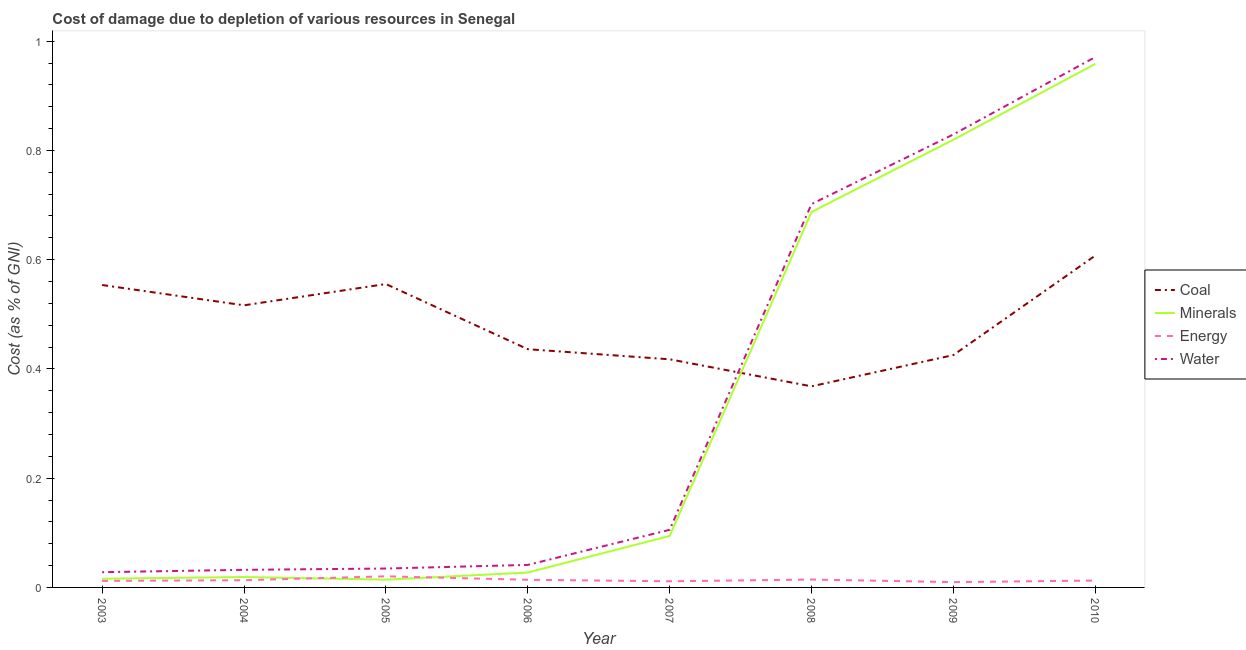How many different coloured lines are there?
Make the answer very short. 4. Does the line corresponding to cost of damage due to depletion of coal intersect with the line corresponding to cost of damage due to depletion of minerals?
Your answer should be compact. Yes. Is the number of lines equal to the number of legend labels?
Your response must be concise. Yes. What is the cost of damage due to depletion of coal in 2010?
Offer a very short reply. 0.61. Across all years, what is the maximum cost of damage due to depletion of water?
Your answer should be very brief. 0.97. Across all years, what is the minimum cost of damage due to depletion of energy?
Offer a terse response. 0.01. In which year was the cost of damage due to depletion of energy maximum?
Offer a terse response. 2005. In which year was the cost of damage due to depletion of energy minimum?
Provide a short and direct response. 2009. What is the total cost of damage due to depletion of minerals in the graph?
Your answer should be compact. 2.64. What is the difference between the cost of damage due to depletion of water in 2003 and that in 2006?
Provide a succinct answer. -0.01. What is the difference between the cost of damage due to depletion of energy in 2006 and the cost of damage due to depletion of coal in 2010?
Your answer should be very brief. -0.59. What is the average cost of damage due to depletion of energy per year?
Ensure brevity in your answer.  0.01. In the year 2009, what is the difference between the cost of damage due to depletion of water and cost of damage due to depletion of coal?
Keep it short and to the point. 0.4. What is the ratio of the cost of damage due to depletion of energy in 2003 to that in 2005?
Your answer should be very brief. 0.59. What is the difference between the highest and the second highest cost of damage due to depletion of coal?
Ensure brevity in your answer.  0.05. What is the difference between the highest and the lowest cost of damage due to depletion of minerals?
Ensure brevity in your answer.  0.94. Is it the case that in every year, the sum of the cost of damage due to depletion of energy and cost of damage due to depletion of minerals is greater than the sum of cost of damage due to depletion of water and cost of damage due to depletion of coal?
Provide a short and direct response. No. Is it the case that in every year, the sum of the cost of damage due to depletion of coal and cost of damage due to depletion of minerals is greater than the cost of damage due to depletion of energy?
Offer a terse response. Yes. Is the cost of damage due to depletion of minerals strictly less than the cost of damage due to depletion of energy over the years?
Make the answer very short. No. How many lines are there?
Your answer should be compact. 4. How many years are there in the graph?
Your answer should be very brief. 8. What is the difference between two consecutive major ticks on the Y-axis?
Offer a very short reply. 0.2. Does the graph contain any zero values?
Offer a very short reply. No. Where does the legend appear in the graph?
Offer a terse response. Center right. How are the legend labels stacked?
Provide a short and direct response. Vertical. What is the title of the graph?
Your response must be concise. Cost of damage due to depletion of various resources in Senegal . Does "Labor Taxes" appear as one of the legend labels in the graph?
Make the answer very short. No. What is the label or title of the Y-axis?
Offer a very short reply. Cost (as % of GNI). What is the Cost (as % of GNI) in Coal in 2003?
Make the answer very short. 0.55. What is the Cost (as % of GNI) of Minerals in 2003?
Ensure brevity in your answer.  0.02. What is the Cost (as % of GNI) in Energy in 2003?
Give a very brief answer. 0.01. What is the Cost (as % of GNI) of Water in 2003?
Make the answer very short. 0.03. What is the Cost (as % of GNI) of Coal in 2004?
Provide a succinct answer. 0.52. What is the Cost (as % of GNI) of Minerals in 2004?
Your answer should be very brief. 0.02. What is the Cost (as % of GNI) of Energy in 2004?
Provide a short and direct response. 0.01. What is the Cost (as % of GNI) of Water in 2004?
Your answer should be very brief. 0.03. What is the Cost (as % of GNI) in Coal in 2005?
Provide a short and direct response. 0.56. What is the Cost (as % of GNI) of Minerals in 2005?
Keep it short and to the point. 0.01. What is the Cost (as % of GNI) of Energy in 2005?
Your answer should be compact. 0.02. What is the Cost (as % of GNI) of Water in 2005?
Your answer should be very brief. 0.03. What is the Cost (as % of GNI) in Coal in 2006?
Make the answer very short. 0.44. What is the Cost (as % of GNI) in Minerals in 2006?
Your response must be concise. 0.03. What is the Cost (as % of GNI) of Energy in 2006?
Provide a succinct answer. 0.01. What is the Cost (as % of GNI) of Water in 2006?
Give a very brief answer. 0.04. What is the Cost (as % of GNI) of Coal in 2007?
Ensure brevity in your answer.  0.42. What is the Cost (as % of GNI) in Minerals in 2007?
Your answer should be compact. 0.09. What is the Cost (as % of GNI) of Energy in 2007?
Offer a terse response. 0.01. What is the Cost (as % of GNI) in Water in 2007?
Keep it short and to the point. 0.11. What is the Cost (as % of GNI) in Coal in 2008?
Your response must be concise. 0.37. What is the Cost (as % of GNI) in Minerals in 2008?
Ensure brevity in your answer.  0.69. What is the Cost (as % of GNI) in Energy in 2008?
Keep it short and to the point. 0.01. What is the Cost (as % of GNI) of Water in 2008?
Make the answer very short. 0.7. What is the Cost (as % of GNI) in Coal in 2009?
Provide a short and direct response. 0.43. What is the Cost (as % of GNI) in Minerals in 2009?
Make the answer very short. 0.82. What is the Cost (as % of GNI) of Energy in 2009?
Ensure brevity in your answer.  0.01. What is the Cost (as % of GNI) of Water in 2009?
Offer a very short reply. 0.83. What is the Cost (as % of GNI) in Coal in 2010?
Provide a short and direct response. 0.61. What is the Cost (as % of GNI) of Minerals in 2010?
Make the answer very short. 0.96. What is the Cost (as % of GNI) in Energy in 2010?
Offer a very short reply. 0.01. What is the Cost (as % of GNI) in Water in 2010?
Offer a terse response. 0.97. Across all years, what is the maximum Cost (as % of GNI) in Coal?
Make the answer very short. 0.61. Across all years, what is the maximum Cost (as % of GNI) of Minerals?
Your response must be concise. 0.96. Across all years, what is the maximum Cost (as % of GNI) of Energy?
Your answer should be very brief. 0.02. Across all years, what is the maximum Cost (as % of GNI) of Water?
Your response must be concise. 0.97. Across all years, what is the minimum Cost (as % of GNI) in Coal?
Provide a short and direct response. 0.37. Across all years, what is the minimum Cost (as % of GNI) of Minerals?
Give a very brief answer. 0.01. Across all years, what is the minimum Cost (as % of GNI) of Energy?
Provide a short and direct response. 0.01. Across all years, what is the minimum Cost (as % of GNI) of Water?
Your response must be concise. 0.03. What is the total Cost (as % of GNI) of Coal in the graph?
Your answer should be compact. 3.88. What is the total Cost (as % of GNI) in Minerals in the graph?
Make the answer very short. 2.64. What is the total Cost (as % of GNI) in Energy in the graph?
Keep it short and to the point. 0.11. What is the total Cost (as % of GNI) in Water in the graph?
Offer a terse response. 2.74. What is the difference between the Cost (as % of GNI) in Coal in 2003 and that in 2004?
Your answer should be compact. 0.04. What is the difference between the Cost (as % of GNI) in Minerals in 2003 and that in 2004?
Keep it short and to the point. -0. What is the difference between the Cost (as % of GNI) in Energy in 2003 and that in 2004?
Offer a very short reply. -0. What is the difference between the Cost (as % of GNI) in Water in 2003 and that in 2004?
Give a very brief answer. -0. What is the difference between the Cost (as % of GNI) in Coal in 2003 and that in 2005?
Your answer should be very brief. -0. What is the difference between the Cost (as % of GNI) in Minerals in 2003 and that in 2005?
Your response must be concise. 0. What is the difference between the Cost (as % of GNI) in Energy in 2003 and that in 2005?
Give a very brief answer. -0.01. What is the difference between the Cost (as % of GNI) in Water in 2003 and that in 2005?
Your answer should be very brief. -0.01. What is the difference between the Cost (as % of GNI) in Coal in 2003 and that in 2006?
Provide a short and direct response. 0.12. What is the difference between the Cost (as % of GNI) in Minerals in 2003 and that in 2006?
Your answer should be compact. -0.01. What is the difference between the Cost (as % of GNI) of Energy in 2003 and that in 2006?
Your answer should be compact. -0. What is the difference between the Cost (as % of GNI) in Water in 2003 and that in 2006?
Your answer should be compact. -0.01. What is the difference between the Cost (as % of GNI) of Coal in 2003 and that in 2007?
Give a very brief answer. 0.14. What is the difference between the Cost (as % of GNI) in Minerals in 2003 and that in 2007?
Your answer should be compact. -0.08. What is the difference between the Cost (as % of GNI) in Energy in 2003 and that in 2007?
Make the answer very short. 0. What is the difference between the Cost (as % of GNI) of Water in 2003 and that in 2007?
Offer a very short reply. -0.08. What is the difference between the Cost (as % of GNI) of Coal in 2003 and that in 2008?
Your response must be concise. 0.19. What is the difference between the Cost (as % of GNI) in Minerals in 2003 and that in 2008?
Your response must be concise. -0.67. What is the difference between the Cost (as % of GNI) in Energy in 2003 and that in 2008?
Ensure brevity in your answer.  -0. What is the difference between the Cost (as % of GNI) in Water in 2003 and that in 2008?
Provide a short and direct response. -0.67. What is the difference between the Cost (as % of GNI) in Coal in 2003 and that in 2009?
Offer a terse response. 0.13. What is the difference between the Cost (as % of GNI) of Minerals in 2003 and that in 2009?
Make the answer very short. -0.8. What is the difference between the Cost (as % of GNI) of Energy in 2003 and that in 2009?
Keep it short and to the point. 0. What is the difference between the Cost (as % of GNI) in Water in 2003 and that in 2009?
Provide a succinct answer. -0.8. What is the difference between the Cost (as % of GNI) of Coal in 2003 and that in 2010?
Give a very brief answer. -0.05. What is the difference between the Cost (as % of GNI) of Minerals in 2003 and that in 2010?
Your answer should be compact. -0.94. What is the difference between the Cost (as % of GNI) of Energy in 2003 and that in 2010?
Make the answer very short. -0. What is the difference between the Cost (as % of GNI) of Water in 2003 and that in 2010?
Your answer should be compact. -0.94. What is the difference between the Cost (as % of GNI) of Coal in 2004 and that in 2005?
Ensure brevity in your answer.  -0.04. What is the difference between the Cost (as % of GNI) of Minerals in 2004 and that in 2005?
Give a very brief answer. 0. What is the difference between the Cost (as % of GNI) in Energy in 2004 and that in 2005?
Your response must be concise. -0.01. What is the difference between the Cost (as % of GNI) of Water in 2004 and that in 2005?
Keep it short and to the point. -0. What is the difference between the Cost (as % of GNI) in Coal in 2004 and that in 2006?
Make the answer very short. 0.08. What is the difference between the Cost (as % of GNI) of Minerals in 2004 and that in 2006?
Your response must be concise. -0.01. What is the difference between the Cost (as % of GNI) of Energy in 2004 and that in 2006?
Your answer should be compact. -0. What is the difference between the Cost (as % of GNI) in Water in 2004 and that in 2006?
Keep it short and to the point. -0.01. What is the difference between the Cost (as % of GNI) of Coal in 2004 and that in 2007?
Offer a terse response. 0.1. What is the difference between the Cost (as % of GNI) in Minerals in 2004 and that in 2007?
Your answer should be compact. -0.08. What is the difference between the Cost (as % of GNI) in Energy in 2004 and that in 2007?
Provide a succinct answer. 0. What is the difference between the Cost (as % of GNI) of Water in 2004 and that in 2007?
Your response must be concise. -0.07. What is the difference between the Cost (as % of GNI) of Coal in 2004 and that in 2008?
Provide a succinct answer. 0.15. What is the difference between the Cost (as % of GNI) of Minerals in 2004 and that in 2008?
Your response must be concise. -0.67. What is the difference between the Cost (as % of GNI) of Energy in 2004 and that in 2008?
Your answer should be compact. -0. What is the difference between the Cost (as % of GNI) in Water in 2004 and that in 2008?
Provide a succinct answer. -0.67. What is the difference between the Cost (as % of GNI) of Coal in 2004 and that in 2009?
Your answer should be compact. 0.09. What is the difference between the Cost (as % of GNI) in Minerals in 2004 and that in 2009?
Offer a terse response. -0.8. What is the difference between the Cost (as % of GNI) in Energy in 2004 and that in 2009?
Your answer should be very brief. 0. What is the difference between the Cost (as % of GNI) of Water in 2004 and that in 2009?
Your response must be concise. -0.8. What is the difference between the Cost (as % of GNI) of Coal in 2004 and that in 2010?
Offer a terse response. -0.09. What is the difference between the Cost (as % of GNI) of Minerals in 2004 and that in 2010?
Provide a short and direct response. -0.94. What is the difference between the Cost (as % of GNI) of Energy in 2004 and that in 2010?
Make the answer very short. 0. What is the difference between the Cost (as % of GNI) of Water in 2004 and that in 2010?
Give a very brief answer. -0.94. What is the difference between the Cost (as % of GNI) of Coal in 2005 and that in 2006?
Ensure brevity in your answer.  0.12. What is the difference between the Cost (as % of GNI) in Minerals in 2005 and that in 2006?
Offer a very short reply. -0.01. What is the difference between the Cost (as % of GNI) of Energy in 2005 and that in 2006?
Offer a terse response. 0.01. What is the difference between the Cost (as % of GNI) in Water in 2005 and that in 2006?
Provide a succinct answer. -0.01. What is the difference between the Cost (as % of GNI) of Coal in 2005 and that in 2007?
Offer a terse response. 0.14. What is the difference between the Cost (as % of GNI) of Minerals in 2005 and that in 2007?
Provide a succinct answer. -0.08. What is the difference between the Cost (as % of GNI) of Energy in 2005 and that in 2007?
Your response must be concise. 0.01. What is the difference between the Cost (as % of GNI) of Water in 2005 and that in 2007?
Your answer should be very brief. -0.07. What is the difference between the Cost (as % of GNI) of Coal in 2005 and that in 2008?
Your answer should be compact. 0.19. What is the difference between the Cost (as % of GNI) in Minerals in 2005 and that in 2008?
Provide a succinct answer. -0.67. What is the difference between the Cost (as % of GNI) of Energy in 2005 and that in 2008?
Your answer should be compact. 0.01. What is the difference between the Cost (as % of GNI) of Water in 2005 and that in 2008?
Your response must be concise. -0.67. What is the difference between the Cost (as % of GNI) of Coal in 2005 and that in 2009?
Keep it short and to the point. 0.13. What is the difference between the Cost (as % of GNI) of Minerals in 2005 and that in 2009?
Make the answer very short. -0.81. What is the difference between the Cost (as % of GNI) of Energy in 2005 and that in 2009?
Keep it short and to the point. 0.01. What is the difference between the Cost (as % of GNI) in Water in 2005 and that in 2009?
Ensure brevity in your answer.  -0.79. What is the difference between the Cost (as % of GNI) of Coal in 2005 and that in 2010?
Your response must be concise. -0.05. What is the difference between the Cost (as % of GNI) in Minerals in 2005 and that in 2010?
Provide a short and direct response. -0.94. What is the difference between the Cost (as % of GNI) of Energy in 2005 and that in 2010?
Keep it short and to the point. 0.01. What is the difference between the Cost (as % of GNI) of Water in 2005 and that in 2010?
Ensure brevity in your answer.  -0.94. What is the difference between the Cost (as % of GNI) in Coal in 2006 and that in 2007?
Ensure brevity in your answer.  0.02. What is the difference between the Cost (as % of GNI) in Minerals in 2006 and that in 2007?
Give a very brief answer. -0.07. What is the difference between the Cost (as % of GNI) in Energy in 2006 and that in 2007?
Give a very brief answer. 0. What is the difference between the Cost (as % of GNI) of Water in 2006 and that in 2007?
Make the answer very short. -0.06. What is the difference between the Cost (as % of GNI) of Coal in 2006 and that in 2008?
Ensure brevity in your answer.  0.07. What is the difference between the Cost (as % of GNI) in Minerals in 2006 and that in 2008?
Offer a very short reply. -0.66. What is the difference between the Cost (as % of GNI) in Energy in 2006 and that in 2008?
Give a very brief answer. -0. What is the difference between the Cost (as % of GNI) in Water in 2006 and that in 2008?
Your answer should be very brief. -0.66. What is the difference between the Cost (as % of GNI) in Coal in 2006 and that in 2009?
Ensure brevity in your answer.  0.01. What is the difference between the Cost (as % of GNI) of Minerals in 2006 and that in 2009?
Offer a terse response. -0.79. What is the difference between the Cost (as % of GNI) of Energy in 2006 and that in 2009?
Give a very brief answer. 0. What is the difference between the Cost (as % of GNI) of Water in 2006 and that in 2009?
Offer a very short reply. -0.79. What is the difference between the Cost (as % of GNI) in Coal in 2006 and that in 2010?
Provide a succinct answer. -0.17. What is the difference between the Cost (as % of GNI) of Minerals in 2006 and that in 2010?
Your answer should be compact. -0.93. What is the difference between the Cost (as % of GNI) in Energy in 2006 and that in 2010?
Provide a succinct answer. 0. What is the difference between the Cost (as % of GNI) in Water in 2006 and that in 2010?
Offer a very short reply. -0.93. What is the difference between the Cost (as % of GNI) of Coal in 2007 and that in 2008?
Give a very brief answer. 0.05. What is the difference between the Cost (as % of GNI) in Minerals in 2007 and that in 2008?
Your answer should be very brief. -0.59. What is the difference between the Cost (as % of GNI) of Energy in 2007 and that in 2008?
Offer a very short reply. -0. What is the difference between the Cost (as % of GNI) of Water in 2007 and that in 2008?
Your response must be concise. -0.6. What is the difference between the Cost (as % of GNI) in Coal in 2007 and that in 2009?
Make the answer very short. -0.01. What is the difference between the Cost (as % of GNI) of Minerals in 2007 and that in 2009?
Keep it short and to the point. -0.73. What is the difference between the Cost (as % of GNI) of Energy in 2007 and that in 2009?
Offer a terse response. 0. What is the difference between the Cost (as % of GNI) in Water in 2007 and that in 2009?
Ensure brevity in your answer.  -0.72. What is the difference between the Cost (as % of GNI) of Coal in 2007 and that in 2010?
Keep it short and to the point. -0.19. What is the difference between the Cost (as % of GNI) of Minerals in 2007 and that in 2010?
Give a very brief answer. -0.86. What is the difference between the Cost (as % of GNI) of Energy in 2007 and that in 2010?
Make the answer very short. -0. What is the difference between the Cost (as % of GNI) in Water in 2007 and that in 2010?
Provide a succinct answer. -0.87. What is the difference between the Cost (as % of GNI) of Coal in 2008 and that in 2009?
Your answer should be compact. -0.06. What is the difference between the Cost (as % of GNI) of Minerals in 2008 and that in 2009?
Keep it short and to the point. -0.13. What is the difference between the Cost (as % of GNI) in Energy in 2008 and that in 2009?
Give a very brief answer. 0. What is the difference between the Cost (as % of GNI) in Water in 2008 and that in 2009?
Offer a terse response. -0.13. What is the difference between the Cost (as % of GNI) of Coal in 2008 and that in 2010?
Provide a succinct answer. -0.24. What is the difference between the Cost (as % of GNI) in Minerals in 2008 and that in 2010?
Your response must be concise. -0.27. What is the difference between the Cost (as % of GNI) in Energy in 2008 and that in 2010?
Offer a very short reply. 0. What is the difference between the Cost (as % of GNI) in Water in 2008 and that in 2010?
Provide a succinct answer. -0.27. What is the difference between the Cost (as % of GNI) in Coal in 2009 and that in 2010?
Provide a short and direct response. -0.18. What is the difference between the Cost (as % of GNI) in Minerals in 2009 and that in 2010?
Make the answer very short. -0.14. What is the difference between the Cost (as % of GNI) of Energy in 2009 and that in 2010?
Your answer should be compact. -0. What is the difference between the Cost (as % of GNI) in Water in 2009 and that in 2010?
Provide a succinct answer. -0.14. What is the difference between the Cost (as % of GNI) in Coal in 2003 and the Cost (as % of GNI) in Minerals in 2004?
Your response must be concise. 0.53. What is the difference between the Cost (as % of GNI) of Coal in 2003 and the Cost (as % of GNI) of Energy in 2004?
Provide a short and direct response. 0.54. What is the difference between the Cost (as % of GNI) of Coal in 2003 and the Cost (as % of GNI) of Water in 2004?
Provide a succinct answer. 0.52. What is the difference between the Cost (as % of GNI) in Minerals in 2003 and the Cost (as % of GNI) in Energy in 2004?
Provide a short and direct response. 0. What is the difference between the Cost (as % of GNI) in Minerals in 2003 and the Cost (as % of GNI) in Water in 2004?
Offer a terse response. -0.02. What is the difference between the Cost (as % of GNI) in Energy in 2003 and the Cost (as % of GNI) in Water in 2004?
Your response must be concise. -0.02. What is the difference between the Cost (as % of GNI) of Coal in 2003 and the Cost (as % of GNI) of Minerals in 2005?
Offer a very short reply. 0.54. What is the difference between the Cost (as % of GNI) in Coal in 2003 and the Cost (as % of GNI) in Energy in 2005?
Offer a terse response. 0.53. What is the difference between the Cost (as % of GNI) in Coal in 2003 and the Cost (as % of GNI) in Water in 2005?
Offer a terse response. 0.52. What is the difference between the Cost (as % of GNI) of Minerals in 2003 and the Cost (as % of GNI) of Energy in 2005?
Your answer should be compact. -0. What is the difference between the Cost (as % of GNI) in Minerals in 2003 and the Cost (as % of GNI) in Water in 2005?
Your answer should be compact. -0.02. What is the difference between the Cost (as % of GNI) of Energy in 2003 and the Cost (as % of GNI) of Water in 2005?
Offer a very short reply. -0.02. What is the difference between the Cost (as % of GNI) of Coal in 2003 and the Cost (as % of GNI) of Minerals in 2006?
Keep it short and to the point. 0.53. What is the difference between the Cost (as % of GNI) of Coal in 2003 and the Cost (as % of GNI) of Energy in 2006?
Keep it short and to the point. 0.54. What is the difference between the Cost (as % of GNI) of Coal in 2003 and the Cost (as % of GNI) of Water in 2006?
Ensure brevity in your answer.  0.51. What is the difference between the Cost (as % of GNI) of Minerals in 2003 and the Cost (as % of GNI) of Energy in 2006?
Ensure brevity in your answer.  0. What is the difference between the Cost (as % of GNI) in Minerals in 2003 and the Cost (as % of GNI) in Water in 2006?
Your response must be concise. -0.03. What is the difference between the Cost (as % of GNI) in Energy in 2003 and the Cost (as % of GNI) in Water in 2006?
Ensure brevity in your answer.  -0.03. What is the difference between the Cost (as % of GNI) of Coal in 2003 and the Cost (as % of GNI) of Minerals in 2007?
Provide a succinct answer. 0.46. What is the difference between the Cost (as % of GNI) of Coal in 2003 and the Cost (as % of GNI) of Energy in 2007?
Give a very brief answer. 0.54. What is the difference between the Cost (as % of GNI) of Coal in 2003 and the Cost (as % of GNI) of Water in 2007?
Provide a short and direct response. 0.45. What is the difference between the Cost (as % of GNI) of Minerals in 2003 and the Cost (as % of GNI) of Energy in 2007?
Offer a terse response. 0. What is the difference between the Cost (as % of GNI) of Minerals in 2003 and the Cost (as % of GNI) of Water in 2007?
Give a very brief answer. -0.09. What is the difference between the Cost (as % of GNI) in Energy in 2003 and the Cost (as % of GNI) in Water in 2007?
Provide a succinct answer. -0.09. What is the difference between the Cost (as % of GNI) of Coal in 2003 and the Cost (as % of GNI) of Minerals in 2008?
Ensure brevity in your answer.  -0.13. What is the difference between the Cost (as % of GNI) of Coal in 2003 and the Cost (as % of GNI) of Energy in 2008?
Your answer should be very brief. 0.54. What is the difference between the Cost (as % of GNI) in Coal in 2003 and the Cost (as % of GNI) in Water in 2008?
Provide a succinct answer. -0.15. What is the difference between the Cost (as % of GNI) in Minerals in 2003 and the Cost (as % of GNI) in Energy in 2008?
Offer a very short reply. 0. What is the difference between the Cost (as % of GNI) of Minerals in 2003 and the Cost (as % of GNI) of Water in 2008?
Your answer should be compact. -0.69. What is the difference between the Cost (as % of GNI) of Energy in 2003 and the Cost (as % of GNI) of Water in 2008?
Ensure brevity in your answer.  -0.69. What is the difference between the Cost (as % of GNI) in Coal in 2003 and the Cost (as % of GNI) in Minerals in 2009?
Your answer should be compact. -0.27. What is the difference between the Cost (as % of GNI) in Coal in 2003 and the Cost (as % of GNI) in Energy in 2009?
Offer a very short reply. 0.54. What is the difference between the Cost (as % of GNI) of Coal in 2003 and the Cost (as % of GNI) of Water in 2009?
Your response must be concise. -0.28. What is the difference between the Cost (as % of GNI) of Minerals in 2003 and the Cost (as % of GNI) of Energy in 2009?
Your answer should be compact. 0.01. What is the difference between the Cost (as % of GNI) of Minerals in 2003 and the Cost (as % of GNI) of Water in 2009?
Provide a short and direct response. -0.81. What is the difference between the Cost (as % of GNI) in Energy in 2003 and the Cost (as % of GNI) in Water in 2009?
Offer a very short reply. -0.82. What is the difference between the Cost (as % of GNI) of Coal in 2003 and the Cost (as % of GNI) of Minerals in 2010?
Keep it short and to the point. -0.4. What is the difference between the Cost (as % of GNI) of Coal in 2003 and the Cost (as % of GNI) of Energy in 2010?
Your answer should be very brief. 0.54. What is the difference between the Cost (as % of GNI) in Coal in 2003 and the Cost (as % of GNI) in Water in 2010?
Keep it short and to the point. -0.42. What is the difference between the Cost (as % of GNI) of Minerals in 2003 and the Cost (as % of GNI) of Energy in 2010?
Keep it short and to the point. 0. What is the difference between the Cost (as % of GNI) of Minerals in 2003 and the Cost (as % of GNI) of Water in 2010?
Ensure brevity in your answer.  -0.95. What is the difference between the Cost (as % of GNI) in Energy in 2003 and the Cost (as % of GNI) in Water in 2010?
Offer a very short reply. -0.96. What is the difference between the Cost (as % of GNI) in Coal in 2004 and the Cost (as % of GNI) in Minerals in 2005?
Your answer should be compact. 0.5. What is the difference between the Cost (as % of GNI) in Coal in 2004 and the Cost (as % of GNI) in Energy in 2005?
Your response must be concise. 0.5. What is the difference between the Cost (as % of GNI) in Coal in 2004 and the Cost (as % of GNI) in Water in 2005?
Offer a terse response. 0.48. What is the difference between the Cost (as % of GNI) of Minerals in 2004 and the Cost (as % of GNI) of Energy in 2005?
Make the answer very short. -0. What is the difference between the Cost (as % of GNI) of Minerals in 2004 and the Cost (as % of GNI) of Water in 2005?
Your response must be concise. -0.02. What is the difference between the Cost (as % of GNI) of Energy in 2004 and the Cost (as % of GNI) of Water in 2005?
Provide a succinct answer. -0.02. What is the difference between the Cost (as % of GNI) in Coal in 2004 and the Cost (as % of GNI) in Minerals in 2006?
Your response must be concise. 0.49. What is the difference between the Cost (as % of GNI) of Coal in 2004 and the Cost (as % of GNI) of Energy in 2006?
Offer a terse response. 0.5. What is the difference between the Cost (as % of GNI) in Coal in 2004 and the Cost (as % of GNI) in Water in 2006?
Offer a very short reply. 0.48. What is the difference between the Cost (as % of GNI) of Minerals in 2004 and the Cost (as % of GNI) of Energy in 2006?
Ensure brevity in your answer.  0.01. What is the difference between the Cost (as % of GNI) in Minerals in 2004 and the Cost (as % of GNI) in Water in 2006?
Ensure brevity in your answer.  -0.02. What is the difference between the Cost (as % of GNI) in Energy in 2004 and the Cost (as % of GNI) in Water in 2006?
Provide a short and direct response. -0.03. What is the difference between the Cost (as % of GNI) in Coal in 2004 and the Cost (as % of GNI) in Minerals in 2007?
Make the answer very short. 0.42. What is the difference between the Cost (as % of GNI) of Coal in 2004 and the Cost (as % of GNI) of Energy in 2007?
Your answer should be very brief. 0.51. What is the difference between the Cost (as % of GNI) of Coal in 2004 and the Cost (as % of GNI) of Water in 2007?
Keep it short and to the point. 0.41. What is the difference between the Cost (as % of GNI) in Minerals in 2004 and the Cost (as % of GNI) in Energy in 2007?
Provide a short and direct response. 0.01. What is the difference between the Cost (as % of GNI) of Minerals in 2004 and the Cost (as % of GNI) of Water in 2007?
Your answer should be compact. -0.09. What is the difference between the Cost (as % of GNI) of Energy in 2004 and the Cost (as % of GNI) of Water in 2007?
Provide a succinct answer. -0.09. What is the difference between the Cost (as % of GNI) of Coal in 2004 and the Cost (as % of GNI) of Minerals in 2008?
Your answer should be very brief. -0.17. What is the difference between the Cost (as % of GNI) in Coal in 2004 and the Cost (as % of GNI) in Energy in 2008?
Your answer should be compact. 0.5. What is the difference between the Cost (as % of GNI) of Coal in 2004 and the Cost (as % of GNI) of Water in 2008?
Ensure brevity in your answer.  -0.19. What is the difference between the Cost (as % of GNI) in Minerals in 2004 and the Cost (as % of GNI) in Energy in 2008?
Your answer should be compact. 0. What is the difference between the Cost (as % of GNI) of Minerals in 2004 and the Cost (as % of GNI) of Water in 2008?
Your answer should be compact. -0.68. What is the difference between the Cost (as % of GNI) of Energy in 2004 and the Cost (as % of GNI) of Water in 2008?
Your response must be concise. -0.69. What is the difference between the Cost (as % of GNI) of Coal in 2004 and the Cost (as % of GNI) of Minerals in 2009?
Provide a succinct answer. -0.3. What is the difference between the Cost (as % of GNI) in Coal in 2004 and the Cost (as % of GNI) in Energy in 2009?
Offer a terse response. 0.51. What is the difference between the Cost (as % of GNI) in Coal in 2004 and the Cost (as % of GNI) in Water in 2009?
Your response must be concise. -0.31. What is the difference between the Cost (as % of GNI) in Minerals in 2004 and the Cost (as % of GNI) in Energy in 2009?
Provide a succinct answer. 0.01. What is the difference between the Cost (as % of GNI) in Minerals in 2004 and the Cost (as % of GNI) in Water in 2009?
Provide a succinct answer. -0.81. What is the difference between the Cost (as % of GNI) of Energy in 2004 and the Cost (as % of GNI) of Water in 2009?
Provide a succinct answer. -0.82. What is the difference between the Cost (as % of GNI) in Coal in 2004 and the Cost (as % of GNI) in Minerals in 2010?
Keep it short and to the point. -0.44. What is the difference between the Cost (as % of GNI) of Coal in 2004 and the Cost (as % of GNI) of Energy in 2010?
Provide a short and direct response. 0.5. What is the difference between the Cost (as % of GNI) in Coal in 2004 and the Cost (as % of GNI) in Water in 2010?
Provide a short and direct response. -0.45. What is the difference between the Cost (as % of GNI) of Minerals in 2004 and the Cost (as % of GNI) of Energy in 2010?
Your answer should be very brief. 0.01. What is the difference between the Cost (as % of GNI) in Minerals in 2004 and the Cost (as % of GNI) in Water in 2010?
Provide a succinct answer. -0.95. What is the difference between the Cost (as % of GNI) of Energy in 2004 and the Cost (as % of GNI) of Water in 2010?
Give a very brief answer. -0.96. What is the difference between the Cost (as % of GNI) of Coal in 2005 and the Cost (as % of GNI) of Minerals in 2006?
Make the answer very short. 0.53. What is the difference between the Cost (as % of GNI) in Coal in 2005 and the Cost (as % of GNI) in Energy in 2006?
Give a very brief answer. 0.54. What is the difference between the Cost (as % of GNI) of Coal in 2005 and the Cost (as % of GNI) of Water in 2006?
Your response must be concise. 0.51. What is the difference between the Cost (as % of GNI) of Minerals in 2005 and the Cost (as % of GNI) of Water in 2006?
Give a very brief answer. -0.03. What is the difference between the Cost (as % of GNI) in Energy in 2005 and the Cost (as % of GNI) in Water in 2006?
Your answer should be very brief. -0.02. What is the difference between the Cost (as % of GNI) of Coal in 2005 and the Cost (as % of GNI) of Minerals in 2007?
Your answer should be very brief. 0.46. What is the difference between the Cost (as % of GNI) in Coal in 2005 and the Cost (as % of GNI) in Energy in 2007?
Provide a short and direct response. 0.54. What is the difference between the Cost (as % of GNI) of Coal in 2005 and the Cost (as % of GNI) of Water in 2007?
Provide a succinct answer. 0.45. What is the difference between the Cost (as % of GNI) of Minerals in 2005 and the Cost (as % of GNI) of Energy in 2007?
Keep it short and to the point. 0. What is the difference between the Cost (as % of GNI) in Minerals in 2005 and the Cost (as % of GNI) in Water in 2007?
Your answer should be compact. -0.09. What is the difference between the Cost (as % of GNI) of Energy in 2005 and the Cost (as % of GNI) of Water in 2007?
Your answer should be compact. -0.09. What is the difference between the Cost (as % of GNI) in Coal in 2005 and the Cost (as % of GNI) in Minerals in 2008?
Provide a short and direct response. -0.13. What is the difference between the Cost (as % of GNI) in Coal in 2005 and the Cost (as % of GNI) in Energy in 2008?
Your response must be concise. 0.54. What is the difference between the Cost (as % of GNI) in Coal in 2005 and the Cost (as % of GNI) in Water in 2008?
Make the answer very short. -0.15. What is the difference between the Cost (as % of GNI) of Minerals in 2005 and the Cost (as % of GNI) of Energy in 2008?
Offer a terse response. -0. What is the difference between the Cost (as % of GNI) in Minerals in 2005 and the Cost (as % of GNI) in Water in 2008?
Your response must be concise. -0.69. What is the difference between the Cost (as % of GNI) in Energy in 2005 and the Cost (as % of GNI) in Water in 2008?
Provide a short and direct response. -0.68. What is the difference between the Cost (as % of GNI) in Coal in 2005 and the Cost (as % of GNI) in Minerals in 2009?
Provide a short and direct response. -0.26. What is the difference between the Cost (as % of GNI) of Coal in 2005 and the Cost (as % of GNI) of Energy in 2009?
Ensure brevity in your answer.  0.55. What is the difference between the Cost (as % of GNI) of Coal in 2005 and the Cost (as % of GNI) of Water in 2009?
Give a very brief answer. -0.27. What is the difference between the Cost (as % of GNI) in Minerals in 2005 and the Cost (as % of GNI) in Energy in 2009?
Make the answer very short. 0. What is the difference between the Cost (as % of GNI) of Minerals in 2005 and the Cost (as % of GNI) of Water in 2009?
Offer a very short reply. -0.82. What is the difference between the Cost (as % of GNI) in Energy in 2005 and the Cost (as % of GNI) in Water in 2009?
Provide a short and direct response. -0.81. What is the difference between the Cost (as % of GNI) in Coal in 2005 and the Cost (as % of GNI) in Minerals in 2010?
Offer a very short reply. -0.4. What is the difference between the Cost (as % of GNI) in Coal in 2005 and the Cost (as % of GNI) in Energy in 2010?
Ensure brevity in your answer.  0.54. What is the difference between the Cost (as % of GNI) of Coal in 2005 and the Cost (as % of GNI) of Water in 2010?
Keep it short and to the point. -0.42. What is the difference between the Cost (as % of GNI) in Minerals in 2005 and the Cost (as % of GNI) in Energy in 2010?
Make the answer very short. 0. What is the difference between the Cost (as % of GNI) of Minerals in 2005 and the Cost (as % of GNI) of Water in 2010?
Give a very brief answer. -0.96. What is the difference between the Cost (as % of GNI) of Energy in 2005 and the Cost (as % of GNI) of Water in 2010?
Keep it short and to the point. -0.95. What is the difference between the Cost (as % of GNI) in Coal in 2006 and the Cost (as % of GNI) in Minerals in 2007?
Your response must be concise. 0.34. What is the difference between the Cost (as % of GNI) of Coal in 2006 and the Cost (as % of GNI) of Energy in 2007?
Offer a very short reply. 0.42. What is the difference between the Cost (as % of GNI) in Coal in 2006 and the Cost (as % of GNI) in Water in 2007?
Offer a very short reply. 0.33. What is the difference between the Cost (as % of GNI) in Minerals in 2006 and the Cost (as % of GNI) in Energy in 2007?
Offer a terse response. 0.02. What is the difference between the Cost (as % of GNI) of Minerals in 2006 and the Cost (as % of GNI) of Water in 2007?
Provide a succinct answer. -0.08. What is the difference between the Cost (as % of GNI) of Energy in 2006 and the Cost (as % of GNI) of Water in 2007?
Your response must be concise. -0.09. What is the difference between the Cost (as % of GNI) in Coal in 2006 and the Cost (as % of GNI) in Minerals in 2008?
Ensure brevity in your answer.  -0.25. What is the difference between the Cost (as % of GNI) in Coal in 2006 and the Cost (as % of GNI) in Energy in 2008?
Your response must be concise. 0.42. What is the difference between the Cost (as % of GNI) in Coal in 2006 and the Cost (as % of GNI) in Water in 2008?
Your response must be concise. -0.27. What is the difference between the Cost (as % of GNI) in Minerals in 2006 and the Cost (as % of GNI) in Energy in 2008?
Offer a very short reply. 0.01. What is the difference between the Cost (as % of GNI) in Minerals in 2006 and the Cost (as % of GNI) in Water in 2008?
Provide a short and direct response. -0.67. What is the difference between the Cost (as % of GNI) of Energy in 2006 and the Cost (as % of GNI) of Water in 2008?
Make the answer very short. -0.69. What is the difference between the Cost (as % of GNI) of Coal in 2006 and the Cost (as % of GNI) of Minerals in 2009?
Ensure brevity in your answer.  -0.38. What is the difference between the Cost (as % of GNI) in Coal in 2006 and the Cost (as % of GNI) in Energy in 2009?
Your response must be concise. 0.43. What is the difference between the Cost (as % of GNI) of Coal in 2006 and the Cost (as % of GNI) of Water in 2009?
Provide a succinct answer. -0.39. What is the difference between the Cost (as % of GNI) in Minerals in 2006 and the Cost (as % of GNI) in Energy in 2009?
Offer a terse response. 0.02. What is the difference between the Cost (as % of GNI) of Minerals in 2006 and the Cost (as % of GNI) of Water in 2009?
Your response must be concise. -0.8. What is the difference between the Cost (as % of GNI) of Energy in 2006 and the Cost (as % of GNI) of Water in 2009?
Offer a very short reply. -0.82. What is the difference between the Cost (as % of GNI) of Coal in 2006 and the Cost (as % of GNI) of Minerals in 2010?
Provide a succinct answer. -0.52. What is the difference between the Cost (as % of GNI) in Coal in 2006 and the Cost (as % of GNI) in Energy in 2010?
Offer a terse response. 0.42. What is the difference between the Cost (as % of GNI) of Coal in 2006 and the Cost (as % of GNI) of Water in 2010?
Your answer should be compact. -0.53. What is the difference between the Cost (as % of GNI) in Minerals in 2006 and the Cost (as % of GNI) in Energy in 2010?
Your response must be concise. 0.01. What is the difference between the Cost (as % of GNI) of Minerals in 2006 and the Cost (as % of GNI) of Water in 2010?
Your answer should be very brief. -0.94. What is the difference between the Cost (as % of GNI) of Energy in 2006 and the Cost (as % of GNI) of Water in 2010?
Make the answer very short. -0.96. What is the difference between the Cost (as % of GNI) of Coal in 2007 and the Cost (as % of GNI) of Minerals in 2008?
Make the answer very short. -0.27. What is the difference between the Cost (as % of GNI) of Coal in 2007 and the Cost (as % of GNI) of Energy in 2008?
Provide a short and direct response. 0.4. What is the difference between the Cost (as % of GNI) of Coal in 2007 and the Cost (as % of GNI) of Water in 2008?
Your response must be concise. -0.28. What is the difference between the Cost (as % of GNI) in Minerals in 2007 and the Cost (as % of GNI) in Energy in 2008?
Provide a succinct answer. 0.08. What is the difference between the Cost (as % of GNI) in Minerals in 2007 and the Cost (as % of GNI) in Water in 2008?
Provide a succinct answer. -0.61. What is the difference between the Cost (as % of GNI) in Energy in 2007 and the Cost (as % of GNI) in Water in 2008?
Make the answer very short. -0.69. What is the difference between the Cost (as % of GNI) of Coal in 2007 and the Cost (as % of GNI) of Minerals in 2009?
Provide a succinct answer. -0.4. What is the difference between the Cost (as % of GNI) of Coal in 2007 and the Cost (as % of GNI) of Energy in 2009?
Provide a succinct answer. 0.41. What is the difference between the Cost (as % of GNI) of Coal in 2007 and the Cost (as % of GNI) of Water in 2009?
Make the answer very short. -0.41. What is the difference between the Cost (as % of GNI) of Minerals in 2007 and the Cost (as % of GNI) of Energy in 2009?
Offer a terse response. 0.08. What is the difference between the Cost (as % of GNI) of Minerals in 2007 and the Cost (as % of GNI) of Water in 2009?
Provide a short and direct response. -0.74. What is the difference between the Cost (as % of GNI) in Energy in 2007 and the Cost (as % of GNI) in Water in 2009?
Provide a succinct answer. -0.82. What is the difference between the Cost (as % of GNI) in Coal in 2007 and the Cost (as % of GNI) in Minerals in 2010?
Keep it short and to the point. -0.54. What is the difference between the Cost (as % of GNI) in Coal in 2007 and the Cost (as % of GNI) in Energy in 2010?
Make the answer very short. 0.41. What is the difference between the Cost (as % of GNI) in Coal in 2007 and the Cost (as % of GNI) in Water in 2010?
Provide a succinct answer. -0.55. What is the difference between the Cost (as % of GNI) in Minerals in 2007 and the Cost (as % of GNI) in Energy in 2010?
Offer a very short reply. 0.08. What is the difference between the Cost (as % of GNI) of Minerals in 2007 and the Cost (as % of GNI) of Water in 2010?
Ensure brevity in your answer.  -0.88. What is the difference between the Cost (as % of GNI) of Energy in 2007 and the Cost (as % of GNI) of Water in 2010?
Your answer should be compact. -0.96. What is the difference between the Cost (as % of GNI) of Coal in 2008 and the Cost (as % of GNI) of Minerals in 2009?
Ensure brevity in your answer.  -0.45. What is the difference between the Cost (as % of GNI) in Coal in 2008 and the Cost (as % of GNI) in Energy in 2009?
Your response must be concise. 0.36. What is the difference between the Cost (as % of GNI) in Coal in 2008 and the Cost (as % of GNI) in Water in 2009?
Give a very brief answer. -0.46. What is the difference between the Cost (as % of GNI) in Minerals in 2008 and the Cost (as % of GNI) in Energy in 2009?
Your answer should be very brief. 0.68. What is the difference between the Cost (as % of GNI) in Minerals in 2008 and the Cost (as % of GNI) in Water in 2009?
Give a very brief answer. -0.14. What is the difference between the Cost (as % of GNI) of Energy in 2008 and the Cost (as % of GNI) of Water in 2009?
Offer a very short reply. -0.81. What is the difference between the Cost (as % of GNI) of Coal in 2008 and the Cost (as % of GNI) of Minerals in 2010?
Your response must be concise. -0.59. What is the difference between the Cost (as % of GNI) of Coal in 2008 and the Cost (as % of GNI) of Energy in 2010?
Make the answer very short. 0.36. What is the difference between the Cost (as % of GNI) of Coal in 2008 and the Cost (as % of GNI) of Water in 2010?
Provide a short and direct response. -0.6. What is the difference between the Cost (as % of GNI) in Minerals in 2008 and the Cost (as % of GNI) in Energy in 2010?
Make the answer very short. 0.67. What is the difference between the Cost (as % of GNI) of Minerals in 2008 and the Cost (as % of GNI) of Water in 2010?
Offer a terse response. -0.28. What is the difference between the Cost (as % of GNI) of Energy in 2008 and the Cost (as % of GNI) of Water in 2010?
Ensure brevity in your answer.  -0.96. What is the difference between the Cost (as % of GNI) of Coal in 2009 and the Cost (as % of GNI) of Minerals in 2010?
Offer a terse response. -0.53. What is the difference between the Cost (as % of GNI) of Coal in 2009 and the Cost (as % of GNI) of Energy in 2010?
Keep it short and to the point. 0.41. What is the difference between the Cost (as % of GNI) in Coal in 2009 and the Cost (as % of GNI) in Water in 2010?
Ensure brevity in your answer.  -0.55. What is the difference between the Cost (as % of GNI) of Minerals in 2009 and the Cost (as % of GNI) of Energy in 2010?
Offer a terse response. 0.81. What is the difference between the Cost (as % of GNI) of Minerals in 2009 and the Cost (as % of GNI) of Water in 2010?
Keep it short and to the point. -0.15. What is the difference between the Cost (as % of GNI) in Energy in 2009 and the Cost (as % of GNI) in Water in 2010?
Offer a very short reply. -0.96. What is the average Cost (as % of GNI) of Coal per year?
Your response must be concise. 0.48. What is the average Cost (as % of GNI) in Minerals per year?
Your answer should be very brief. 0.33. What is the average Cost (as % of GNI) of Energy per year?
Give a very brief answer. 0.01. What is the average Cost (as % of GNI) in Water per year?
Provide a short and direct response. 0.34. In the year 2003, what is the difference between the Cost (as % of GNI) in Coal and Cost (as % of GNI) in Minerals?
Make the answer very short. 0.54. In the year 2003, what is the difference between the Cost (as % of GNI) in Coal and Cost (as % of GNI) in Energy?
Your answer should be compact. 0.54. In the year 2003, what is the difference between the Cost (as % of GNI) in Coal and Cost (as % of GNI) in Water?
Ensure brevity in your answer.  0.53. In the year 2003, what is the difference between the Cost (as % of GNI) in Minerals and Cost (as % of GNI) in Energy?
Keep it short and to the point. 0. In the year 2003, what is the difference between the Cost (as % of GNI) in Minerals and Cost (as % of GNI) in Water?
Provide a short and direct response. -0.01. In the year 2003, what is the difference between the Cost (as % of GNI) in Energy and Cost (as % of GNI) in Water?
Make the answer very short. -0.02. In the year 2004, what is the difference between the Cost (as % of GNI) in Coal and Cost (as % of GNI) in Minerals?
Your response must be concise. 0.5. In the year 2004, what is the difference between the Cost (as % of GNI) in Coal and Cost (as % of GNI) in Energy?
Keep it short and to the point. 0.5. In the year 2004, what is the difference between the Cost (as % of GNI) of Coal and Cost (as % of GNI) of Water?
Provide a succinct answer. 0.48. In the year 2004, what is the difference between the Cost (as % of GNI) of Minerals and Cost (as % of GNI) of Energy?
Provide a short and direct response. 0.01. In the year 2004, what is the difference between the Cost (as % of GNI) of Minerals and Cost (as % of GNI) of Water?
Offer a very short reply. -0.01. In the year 2004, what is the difference between the Cost (as % of GNI) in Energy and Cost (as % of GNI) in Water?
Your answer should be very brief. -0.02. In the year 2005, what is the difference between the Cost (as % of GNI) of Coal and Cost (as % of GNI) of Minerals?
Give a very brief answer. 0.54. In the year 2005, what is the difference between the Cost (as % of GNI) in Coal and Cost (as % of GNI) in Energy?
Provide a succinct answer. 0.54. In the year 2005, what is the difference between the Cost (as % of GNI) in Coal and Cost (as % of GNI) in Water?
Make the answer very short. 0.52. In the year 2005, what is the difference between the Cost (as % of GNI) of Minerals and Cost (as % of GNI) of Energy?
Provide a short and direct response. -0.01. In the year 2005, what is the difference between the Cost (as % of GNI) of Minerals and Cost (as % of GNI) of Water?
Provide a short and direct response. -0.02. In the year 2005, what is the difference between the Cost (as % of GNI) of Energy and Cost (as % of GNI) of Water?
Offer a terse response. -0.01. In the year 2006, what is the difference between the Cost (as % of GNI) of Coal and Cost (as % of GNI) of Minerals?
Offer a terse response. 0.41. In the year 2006, what is the difference between the Cost (as % of GNI) in Coal and Cost (as % of GNI) in Energy?
Make the answer very short. 0.42. In the year 2006, what is the difference between the Cost (as % of GNI) in Coal and Cost (as % of GNI) in Water?
Offer a very short reply. 0.39. In the year 2006, what is the difference between the Cost (as % of GNI) of Minerals and Cost (as % of GNI) of Energy?
Offer a very short reply. 0.01. In the year 2006, what is the difference between the Cost (as % of GNI) in Minerals and Cost (as % of GNI) in Water?
Ensure brevity in your answer.  -0.01. In the year 2006, what is the difference between the Cost (as % of GNI) of Energy and Cost (as % of GNI) of Water?
Offer a terse response. -0.03. In the year 2007, what is the difference between the Cost (as % of GNI) in Coal and Cost (as % of GNI) in Minerals?
Keep it short and to the point. 0.32. In the year 2007, what is the difference between the Cost (as % of GNI) in Coal and Cost (as % of GNI) in Energy?
Keep it short and to the point. 0.41. In the year 2007, what is the difference between the Cost (as % of GNI) of Coal and Cost (as % of GNI) of Water?
Give a very brief answer. 0.31. In the year 2007, what is the difference between the Cost (as % of GNI) of Minerals and Cost (as % of GNI) of Energy?
Provide a short and direct response. 0.08. In the year 2007, what is the difference between the Cost (as % of GNI) of Minerals and Cost (as % of GNI) of Water?
Keep it short and to the point. -0.01. In the year 2007, what is the difference between the Cost (as % of GNI) in Energy and Cost (as % of GNI) in Water?
Give a very brief answer. -0.09. In the year 2008, what is the difference between the Cost (as % of GNI) in Coal and Cost (as % of GNI) in Minerals?
Give a very brief answer. -0.32. In the year 2008, what is the difference between the Cost (as % of GNI) in Coal and Cost (as % of GNI) in Energy?
Give a very brief answer. 0.35. In the year 2008, what is the difference between the Cost (as % of GNI) of Coal and Cost (as % of GNI) of Water?
Your response must be concise. -0.33. In the year 2008, what is the difference between the Cost (as % of GNI) in Minerals and Cost (as % of GNI) in Energy?
Keep it short and to the point. 0.67. In the year 2008, what is the difference between the Cost (as % of GNI) in Minerals and Cost (as % of GNI) in Water?
Give a very brief answer. -0.01. In the year 2008, what is the difference between the Cost (as % of GNI) in Energy and Cost (as % of GNI) in Water?
Give a very brief answer. -0.69. In the year 2009, what is the difference between the Cost (as % of GNI) in Coal and Cost (as % of GNI) in Minerals?
Your answer should be compact. -0.39. In the year 2009, what is the difference between the Cost (as % of GNI) in Coal and Cost (as % of GNI) in Energy?
Provide a succinct answer. 0.42. In the year 2009, what is the difference between the Cost (as % of GNI) in Coal and Cost (as % of GNI) in Water?
Keep it short and to the point. -0.4. In the year 2009, what is the difference between the Cost (as % of GNI) in Minerals and Cost (as % of GNI) in Energy?
Your answer should be very brief. 0.81. In the year 2009, what is the difference between the Cost (as % of GNI) of Minerals and Cost (as % of GNI) of Water?
Give a very brief answer. -0.01. In the year 2009, what is the difference between the Cost (as % of GNI) of Energy and Cost (as % of GNI) of Water?
Your answer should be compact. -0.82. In the year 2010, what is the difference between the Cost (as % of GNI) in Coal and Cost (as % of GNI) in Minerals?
Keep it short and to the point. -0.35. In the year 2010, what is the difference between the Cost (as % of GNI) of Coal and Cost (as % of GNI) of Energy?
Make the answer very short. 0.59. In the year 2010, what is the difference between the Cost (as % of GNI) of Coal and Cost (as % of GNI) of Water?
Your answer should be very brief. -0.36. In the year 2010, what is the difference between the Cost (as % of GNI) of Minerals and Cost (as % of GNI) of Energy?
Offer a terse response. 0.95. In the year 2010, what is the difference between the Cost (as % of GNI) in Minerals and Cost (as % of GNI) in Water?
Provide a succinct answer. -0.01. In the year 2010, what is the difference between the Cost (as % of GNI) of Energy and Cost (as % of GNI) of Water?
Ensure brevity in your answer.  -0.96. What is the ratio of the Cost (as % of GNI) in Coal in 2003 to that in 2004?
Offer a terse response. 1.07. What is the ratio of the Cost (as % of GNI) in Minerals in 2003 to that in 2004?
Ensure brevity in your answer.  0.84. What is the ratio of the Cost (as % of GNI) in Energy in 2003 to that in 2004?
Provide a short and direct response. 0.91. What is the ratio of the Cost (as % of GNI) in Water in 2003 to that in 2004?
Give a very brief answer. 0.86. What is the ratio of the Cost (as % of GNI) in Minerals in 2003 to that in 2005?
Provide a succinct answer. 1.12. What is the ratio of the Cost (as % of GNI) in Energy in 2003 to that in 2005?
Offer a terse response. 0.59. What is the ratio of the Cost (as % of GNI) in Water in 2003 to that in 2005?
Keep it short and to the point. 0.81. What is the ratio of the Cost (as % of GNI) of Coal in 2003 to that in 2006?
Offer a terse response. 1.27. What is the ratio of the Cost (as % of GNI) in Minerals in 2003 to that in 2006?
Keep it short and to the point. 0.59. What is the ratio of the Cost (as % of GNI) in Energy in 2003 to that in 2006?
Offer a terse response. 0.85. What is the ratio of the Cost (as % of GNI) in Water in 2003 to that in 2006?
Ensure brevity in your answer.  0.68. What is the ratio of the Cost (as % of GNI) of Coal in 2003 to that in 2007?
Make the answer very short. 1.33. What is the ratio of the Cost (as % of GNI) in Minerals in 2003 to that in 2007?
Your answer should be compact. 0.17. What is the ratio of the Cost (as % of GNI) of Energy in 2003 to that in 2007?
Provide a succinct answer. 1.06. What is the ratio of the Cost (as % of GNI) in Water in 2003 to that in 2007?
Give a very brief answer. 0.26. What is the ratio of the Cost (as % of GNI) in Coal in 2003 to that in 2008?
Your answer should be very brief. 1.5. What is the ratio of the Cost (as % of GNI) in Minerals in 2003 to that in 2008?
Make the answer very short. 0.02. What is the ratio of the Cost (as % of GNI) of Energy in 2003 to that in 2008?
Your answer should be compact. 0.83. What is the ratio of the Cost (as % of GNI) in Water in 2003 to that in 2008?
Offer a terse response. 0.04. What is the ratio of the Cost (as % of GNI) of Coal in 2003 to that in 2009?
Make the answer very short. 1.3. What is the ratio of the Cost (as % of GNI) of Minerals in 2003 to that in 2009?
Give a very brief answer. 0.02. What is the ratio of the Cost (as % of GNI) of Energy in 2003 to that in 2009?
Your response must be concise. 1.23. What is the ratio of the Cost (as % of GNI) of Water in 2003 to that in 2009?
Ensure brevity in your answer.  0.03. What is the ratio of the Cost (as % of GNI) in Coal in 2003 to that in 2010?
Offer a terse response. 0.91. What is the ratio of the Cost (as % of GNI) in Minerals in 2003 to that in 2010?
Provide a succinct answer. 0.02. What is the ratio of the Cost (as % of GNI) in Energy in 2003 to that in 2010?
Provide a short and direct response. 0.95. What is the ratio of the Cost (as % of GNI) in Water in 2003 to that in 2010?
Your response must be concise. 0.03. What is the ratio of the Cost (as % of GNI) of Coal in 2004 to that in 2005?
Provide a short and direct response. 0.93. What is the ratio of the Cost (as % of GNI) in Minerals in 2004 to that in 2005?
Give a very brief answer. 1.34. What is the ratio of the Cost (as % of GNI) of Energy in 2004 to that in 2005?
Offer a very short reply. 0.65. What is the ratio of the Cost (as % of GNI) of Water in 2004 to that in 2005?
Give a very brief answer. 0.93. What is the ratio of the Cost (as % of GNI) of Coal in 2004 to that in 2006?
Keep it short and to the point. 1.18. What is the ratio of the Cost (as % of GNI) of Minerals in 2004 to that in 2006?
Give a very brief answer. 0.7. What is the ratio of the Cost (as % of GNI) in Energy in 2004 to that in 2006?
Make the answer very short. 0.94. What is the ratio of the Cost (as % of GNI) in Water in 2004 to that in 2006?
Provide a succinct answer. 0.78. What is the ratio of the Cost (as % of GNI) in Coal in 2004 to that in 2007?
Provide a short and direct response. 1.24. What is the ratio of the Cost (as % of GNI) in Minerals in 2004 to that in 2007?
Your response must be concise. 0.2. What is the ratio of the Cost (as % of GNI) in Energy in 2004 to that in 2007?
Make the answer very short. 1.17. What is the ratio of the Cost (as % of GNI) of Water in 2004 to that in 2007?
Ensure brevity in your answer.  0.31. What is the ratio of the Cost (as % of GNI) of Coal in 2004 to that in 2008?
Offer a terse response. 1.4. What is the ratio of the Cost (as % of GNI) in Minerals in 2004 to that in 2008?
Keep it short and to the point. 0.03. What is the ratio of the Cost (as % of GNI) in Energy in 2004 to that in 2008?
Offer a very short reply. 0.91. What is the ratio of the Cost (as % of GNI) in Water in 2004 to that in 2008?
Keep it short and to the point. 0.05. What is the ratio of the Cost (as % of GNI) of Coal in 2004 to that in 2009?
Your answer should be compact. 1.21. What is the ratio of the Cost (as % of GNI) of Minerals in 2004 to that in 2009?
Keep it short and to the point. 0.02. What is the ratio of the Cost (as % of GNI) of Energy in 2004 to that in 2009?
Offer a very short reply. 1.36. What is the ratio of the Cost (as % of GNI) in Water in 2004 to that in 2009?
Provide a succinct answer. 0.04. What is the ratio of the Cost (as % of GNI) of Coal in 2004 to that in 2010?
Ensure brevity in your answer.  0.85. What is the ratio of the Cost (as % of GNI) in Minerals in 2004 to that in 2010?
Offer a terse response. 0.02. What is the ratio of the Cost (as % of GNI) of Energy in 2004 to that in 2010?
Keep it short and to the point. 1.05. What is the ratio of the Cost (as % of GNI) in Water in 2004 to that in 2010?
Keep it short and to the point. 0.03. What is the ratio of the Cost (as % of GNI) of Coal in 2005 to that in 2006?
Offer a terse response. 1.27. What is the ratio of the Cost (as % of GNI) in Minerals in 2005 to that in 2006?
Offer a terse response. 0.52. What is the ratio of the Cost (as % of GNI) of Energy in 2005 to that in 2006?
Offer a very short reply. 1.46. What is the ratio of the Cost (as % of GNI) of Water in 2005 to that in 2006?
Ensure brevity in your answer.  0.84. What is the ratio of the Cost (as % of GNI) of Coal in 2005 to that in 2007?
Make the answer very short. 1.33. What is the ratio of the Cost (as % of GNI) in Minerals in 2005 to that in 2007?
Make the answer very short. 0.15. What is the ratio of the Cost (as % of GNI) in Energy in 2005 to that in 2007?
Make the answer very short. 1.81. What is the ratio of the Cost (as % of GNI) of Water in 2005 to that in 2007?
Provide a short and direct response. 0.33. What is the ratio of the Cost (as % of GNI) of Coal in 2005 to that in 2008?
Ensure brevity in your answer.  1.51. What is the ratio of the Cost (as % of GNI) of Minerals in 2005 to that in 2008?
Your answer should be very brief. 0.02. What is the ratio of the Cost (as % of GNI) of Energy in 2005 to that in 2008?
Make the answer very short. 1.41. What is the ratio of the Cost (as % of GNI) of Water in 2005 to that in 2008?
Keep it short and to the point. 0.05. What is the ratio of the Cost (as % of GNI) of Coal in 2005 to that in 2009?
Your answer should be compact. 1.31. What is the ratio of the Cost (as % of GNI) of Minerals in 2005 to that in 2009?
Offer a terse response. 0.02. What is the ratio of the Cost (as % of GNI) in Energy in 2005 to that in 2009?
Your answer should be very brief. 2.09. What is the ratio of the Cost (as % of GNI) in Water in 2005 to that in 2009?
Keep it short and to the point. 0.04. What is the ratio of the Cost (as % of GNI) of Coal in 2005 to that in 2010?
Your response must be concise. 0.91. What is the ratio of the Cost (as % of GNI) in Minerals in 2005 to that in 2010?
Make the answer very short. 0.01. What is the ratio of the Cost (as % of GNI) of Energy in 2005 to that in 2010?
Offer a very short reply. 1.62. What is the ratio of the Cost (as % of GNI) in Water in 2005 to that in 2010?
Your answer should be compact. 0.04. What is the ratio of the Cost (as % of GNI) of Coal in 2006 to that in 2007?
Offer a very short reply. 1.04. What is the ratio of the Cost (as % of GNI) of Minerals in 2006 to that in 2007?
Your answer should be compact. 0.29. What is the ratio of the Cost (as % of GNI) of Energy in 2006 to that in 2007?
Offer a terse response. 1.24. What is the ratio of the Cost (as % of GNI) of Water in 2006 to that in 2007?
Your answer should be compact. 0.39. What is the ratio of the Cost (as % of GNI) in Coal in 2006 to that in 2008?
Offer a terse response. 1.18. What is the ratio of the Cost (as % of GNI) in Minerals in 2006 to that in 2008?
Your answer should be very brief. 0.04. What is the ratio of the Cost (as % of GNI) in Energy in 2006 to that in 2008?
Keep it short and to the point. 0.97. What is the ratio of the Cost (as % of GNI) in Water in 2006 to that in 2008?
Offer a very short reply. 0.06. What is the ratio of the Cost (as % of GNI) in Coal in 2006 to that in 2009?
Your response must be concise. 1.03. What is the ratio of the Cost (as % of GNI) in Minerals in 2006 to that in 2009?
Your response must be concise. 0.03. What is the ratio of the Cost (as % of GNI) in Energy in 2006 to that in 2009?
Keep it short and to the point. 1.44. What is the ratio of the Cost (as % of GNI) of Water in 2006 to that in 2009?
Provide a succinct answer. 0.05. What is the ratio of the Cost (as % of GNI) in Coal in 2006 to that in 2010?
Give a very brief answer. 0.72. What is the ratio of the Cost (as % of GNI) of Minerals in 2006 to that in 2010?
Provide a short and direct response. 0.03. What is the ratio of the Cost (as % of GNI) in Energy in 2006 to that in 2010?
Your answer should be very brief. 1.11. What is the ratio of the Cost (as % of GNI) of Water in 2006 to that in 2010?
Your response must be concise. 0.04. What is the ratio of the Cost (as % of GNI) of Coal in 2007 to that in 2008?
Keep it short and to the point. 1.13. What is the ratio of the Cost (as % of GNI) in Minerals in 2007 to that in 2008?
Make the answer very short. 0.14. What is the ratio of the Cost (as % of GNI) of Energy in 2007 to that in 2008?
Ensure brevity in your answer.  0.78. What is the ratio of the Cost (as % of GNI) of Water in 2007 to that in 2008?
Provide a short and direct response. 0.15. What is the ratio of the Cost (as % of GNI) in Coal in 2007 to that in 2009?
Your answer should be compact. 0.98. What is the ratio of the Cost (as % of GNI) of Minerals in 2007 to that in 2009?
Offer a terse response. 0.12. What is the ratio of the Cost (as % of GNI) of Energy in 2007 to that in 2009?
Your response must be concise. 1.16. What is the ratio of the Cost (as % of GNI) in Water in 2007 to that in 2009?
Offer a very short reply. 0.13. What is the ratio of the Cost (as % of GNI) of Coal in 2007 to that in 2010?
Provide a short and direct response. 0.69. What is the ratio of the Cost (as % of GNI) in Minerals in 2007 to that in 2010?
Ensure brevity in your answer.  0.1. What is the ratio of the Cost (as % of GNI) in Energy in 2007 to that in 2010?
Your response must be concise. 0.89. What is the ratio of the Cost (as % of GNI) in Water in 2007 to that in 2010?
Keep it short and to the point. 0.11. What is the ratio of the Cost (as % of GNI) of Coal in 2008 to that in 2009?
Your answer should be very brief. 0.87. What is the ratio of the Cost (as % of GNI) in Minerals in 2008 to that in 2009?
Your answer should be very brief. 0.84. What is the ratio of the Cost (as % of GNI) of Energy in 2008 to that in 2009?
Your answer should be very brief. 1.48. What is the ratio of the Cost (as % of GNI) in Water in 2008 to that in 2009?
Give a very brief answer. 0.85. What is the ratio of the Cost (as % of GNI) of Coal in 2008 to that in 2010?
Your answer should be very brief. 0.61. What is the ratio of the Cost (as % of GNI) in Minerals in 2008 to that in 2010?
Give a very brief answer. 0.72. What is the ratio of the Cost (as % of GNI) of Energy in 2008 to that in 2010?
Your response must be concise. 1.15. What is the ratio of the Cost (as % of GNI) in Water in 2008 to that in 2010?
Your answer should be very brief. 0.72. What is the ratio of the Cost (as % of GNI) in Coal in 2009 to that in 2010?
Keep it short and to the point. 0.7. What is the ratio of the Cost (as % of GNI) in Minerals in 2009 to that in 2010?
Offer a very short reply. 0.86. What is the ratio of the Cost (as % of GNI) in Energy in 2009 to that in 2010?
Keep it short and to the point. 0.77. What is the ratio of the Cost (as % of GNI) of Water in 2009 to that in 2010?
Offer a very short reply. 0.85. What is the difference between the highest and the second highest Cost (as % of GNI) of Coal?
Give a very brief answer. 0.05. What is the difference between the highest and the second highest Cost (as % of GNI) of Minerals?
Ensure brevity in your answer.  0.14. What is the difference between the highest and the second highest Cost (as % of GNI) of Energy?
Offer a very short reply. 0.01. What is the difference between the highest and the second highest Cost (as % of GNI) of Water?
Ensure brevity in your answer.  0.14. What is the difference between the highest and the lowest Cost (as % of GNI) of Coal?
Provide a short and direct response. 0.24. What is the difference between the highest and the lowest Cost (as % of GNI) in Minerals?
Give a very brief answer. 0.94. What is the difference between the highest and the lowest Cost (as % of GNI) of Energy?
Keep it short and to the point. 0.01. What is the difference between the highest and the lowest Cost (as % of GNI) in Water?
Your answer should be compact. 0.94. 